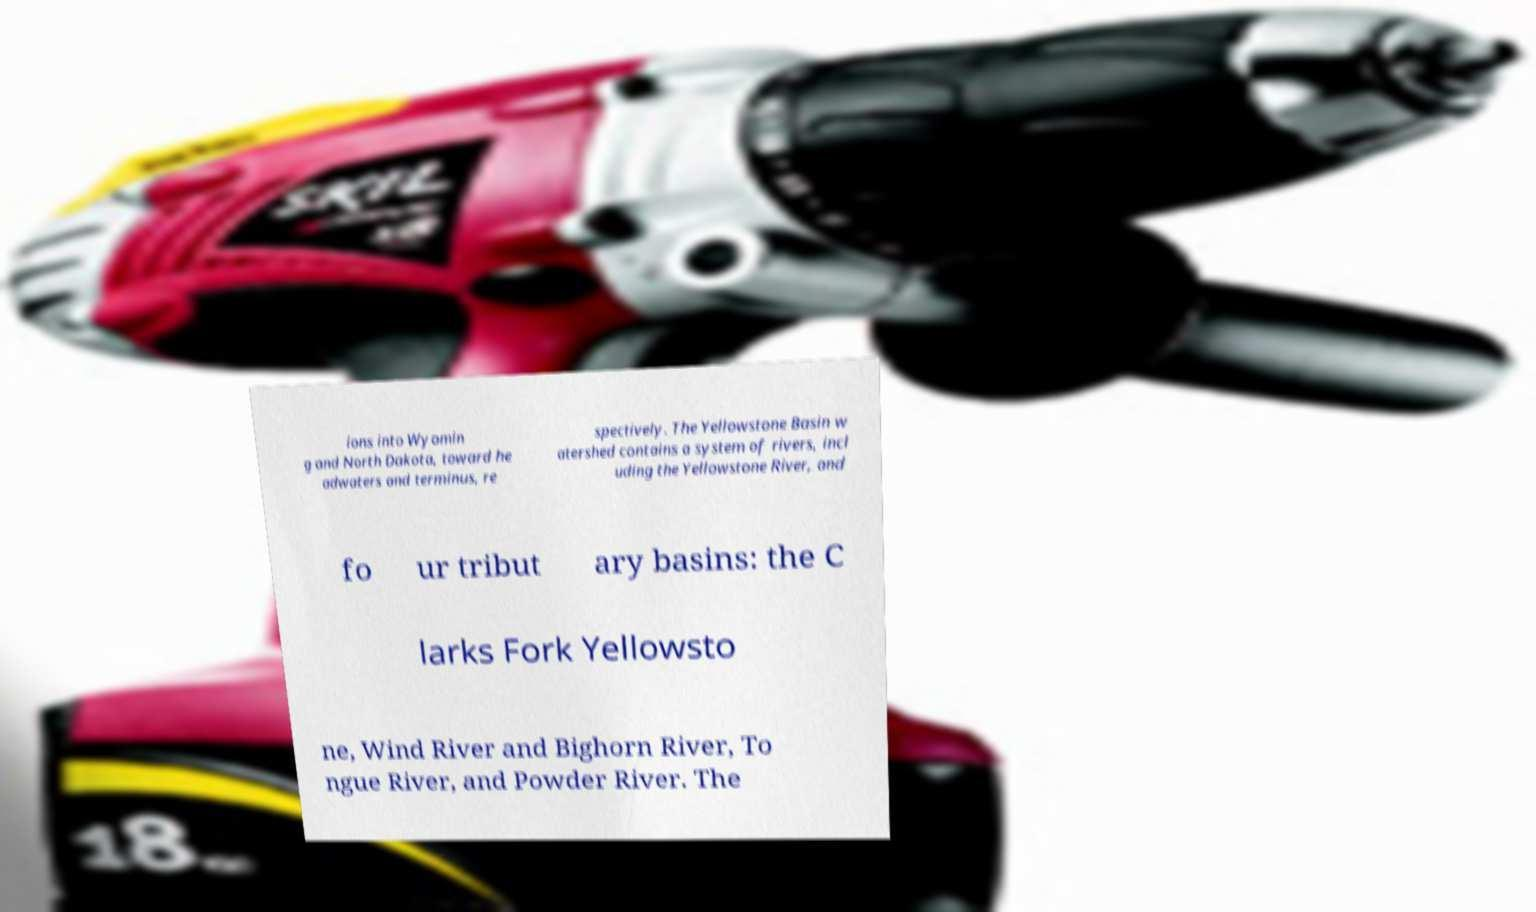For documentation purposes, I need the text within this image transcribed. Could you provide that? ions into Wyomin g and North Dakota, toward he adwaters and terminus, re spectively. The Yellowstone Basin w atershed contains a system of rivers, incl uding the Yellowstone River, and fo ur tribut ary basins: the C larks Fork Yellowsto ne, Wind River and Bighorn River, To ngue River, and Powder River. The 